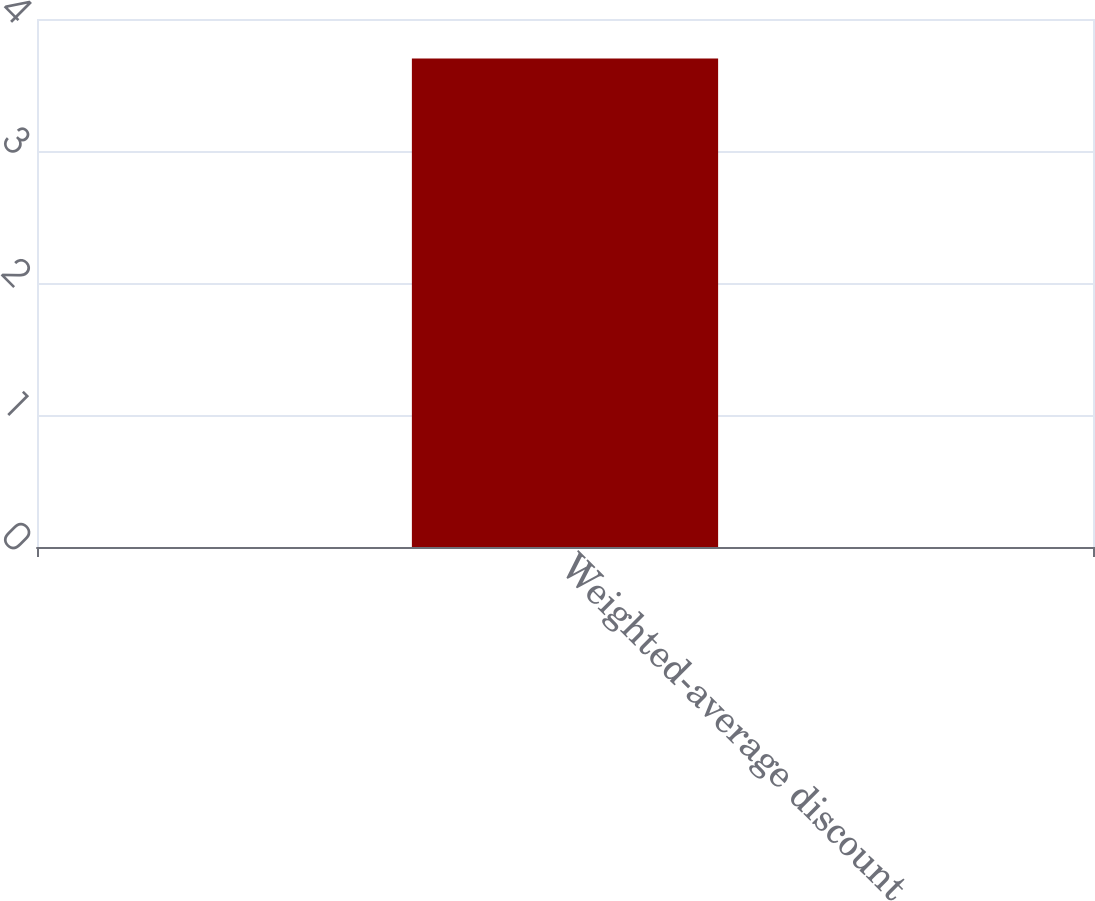Convert chart to OTSL. <chart><loc_0><loc_0><loc_500><loc_500><bar_chart><fcel>Weighted-average discount<nl><fcel>3.7<nl></chart> 